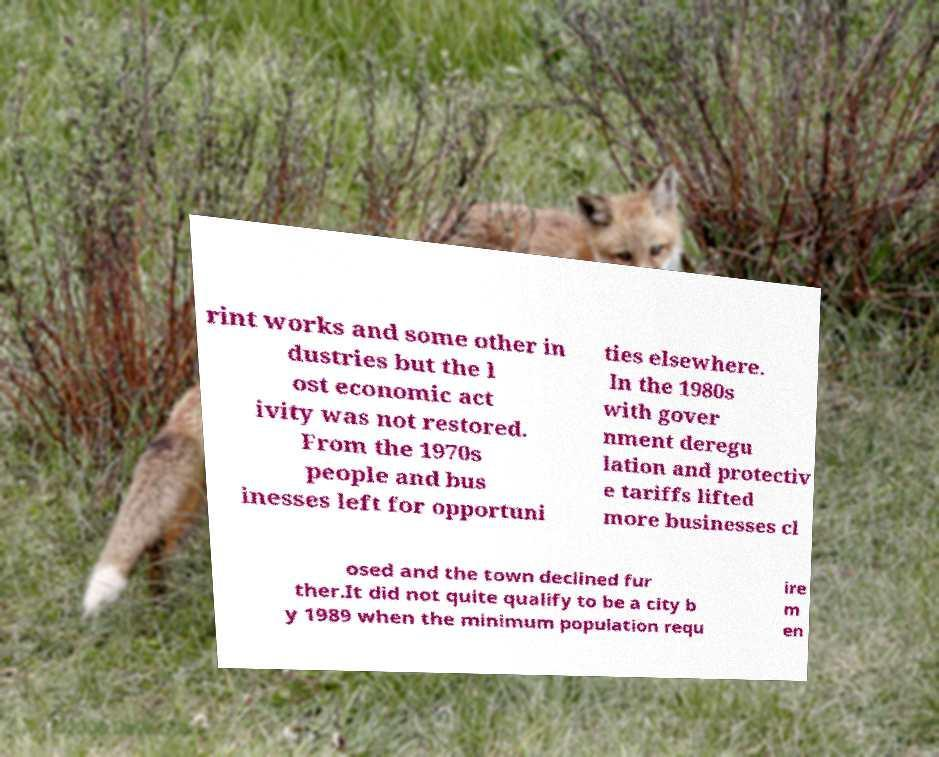Please read and relay the text visible in this image. What does it say? rint works and some other in dustries but the l ost economic act ivity was not restored. From the 1970s people and bus inesses left for opportuni ties elsewhere. In the 1980s with gover nment deregu lation and protectiv e tariffs lifted more businesses cl osed and the town declined fur ther.It did not quite qualify to be a city b y 1989 when the minimum population requ ire m en 